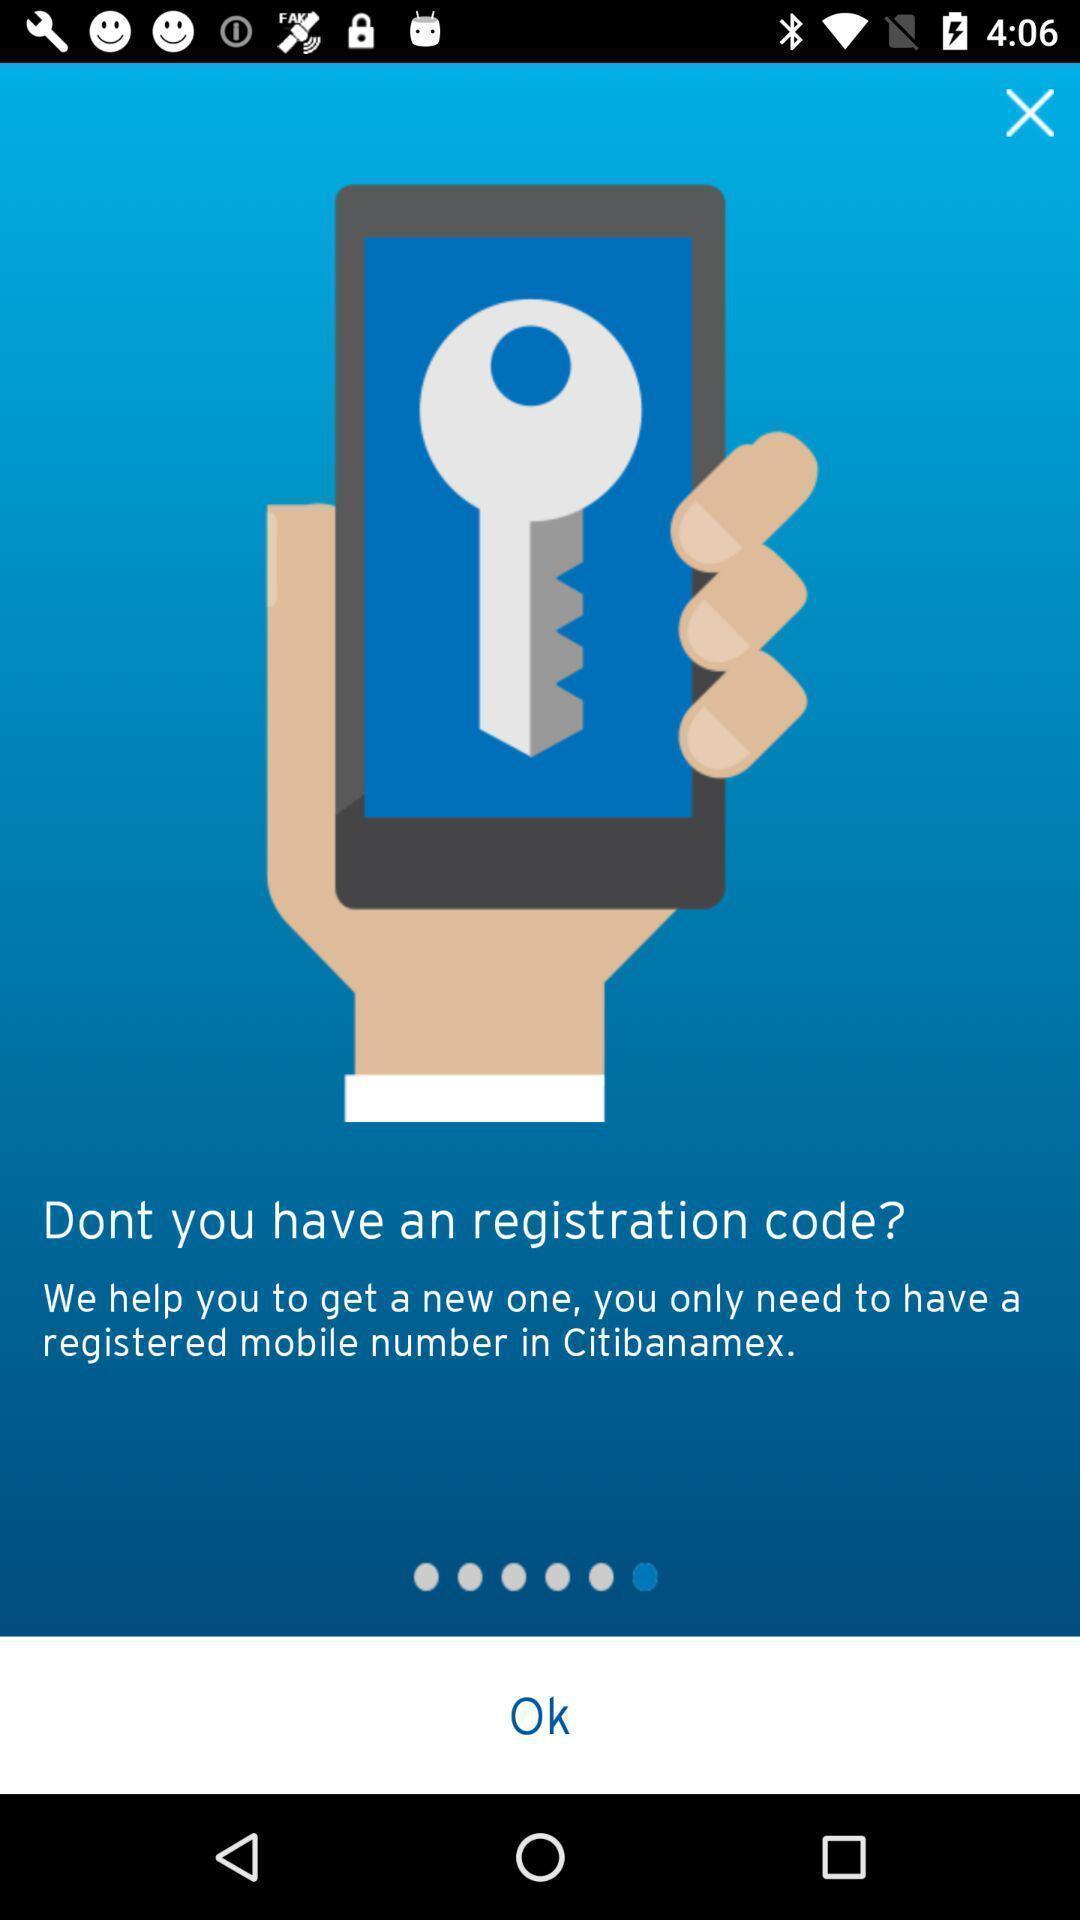Explain the elements present in this screenshot. Welcome page. 